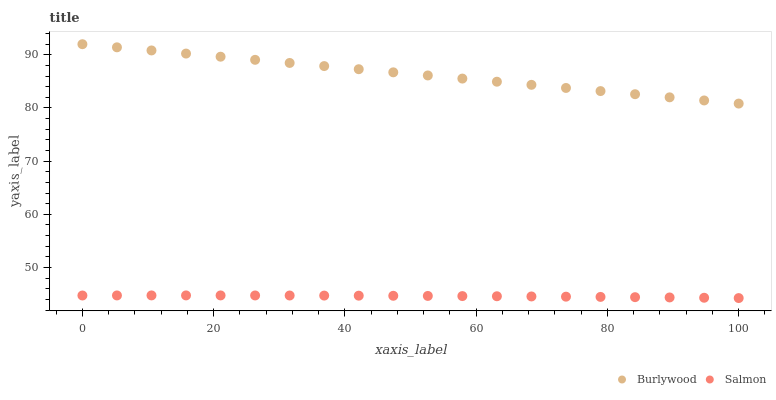Does Salmon have the minimum area under the curve?
Answer yes or no. Yes. Does Burlywood have the maximum area under the curve?
Answer yes or no. Yes. Does Salmon have the maximum area under the curve?
Answer yes or no. No. Is Burlywood the smoothest?
Answer yes or no. Yes. Is Salmon the roughest?
Answer yes or no. Yes. Is Salmon the smoothest?
Answer yes or no. No. Does Salmon have the lowest value?
Answer yes or no. Yes. Does Burlywood have the highest value?
Answer yes or no. Yes. Does Salmon have the highest value?
Answer yes or no. No. Is Salmon less than Burlywood?
Answer yes or no. Yes. Is Burlywood greater than Salmon?
Answer yes or no. Yes. Does Salmon intersect Burlywood?
Answer yes or no. No. 